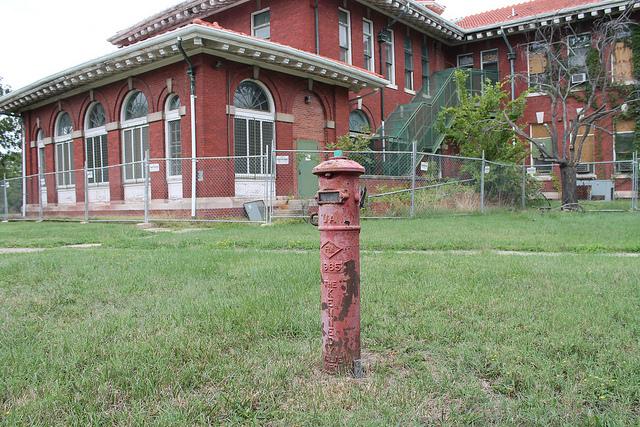Can an open door be seen?
Keep it brief. No. Is there a metal fence around the building?
Keep it brief. Yes. What is the closest object in the picture?
Short answer required. Hydrant. What color are the stairs?
Answer briefly. Green. 